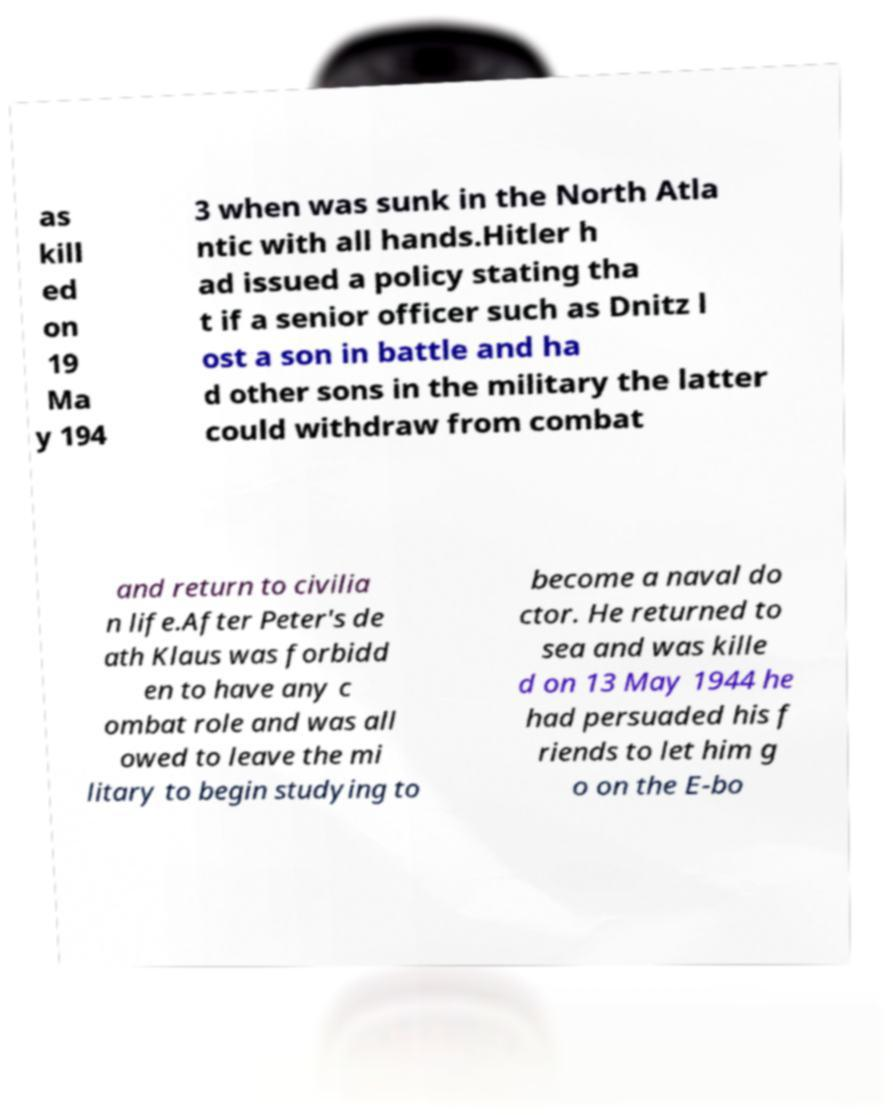I need the written content from this picture converted into text. Can you do that? as kill ed on 19 Ma y 194 3 when was sunk in the North Atla ntic with all hands.Hitler h ad issued a policy stating tha t if a senior officer such as Dnitz l ost a son in battle and ha d other sons in the military the latter could withdraw from combat and return to civilia n life.After Peter's de ath Klaus was forbidd en to have any c ombat role and was all owed to leave the mi litary to begin studying to become a naval do ctor. He returned to sea and was kille d on 13 May 1944 he had persuaded his f riends to let him g o on the E-bo 